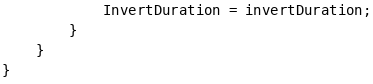<code> <loc_0><loc_0><loc_500><loc_500><_C#_>            InvertDuration = invertDuration;
        }
    }
}
</code> 